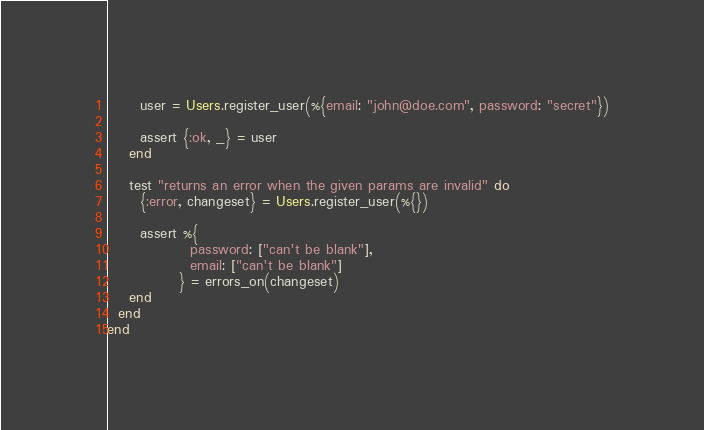<code> <loc_0><loc_0><loc_500><loc_500><_Elixir_>      user = Users.register_user(%{email: "john@doe.com", password: "secret"})

      assert {:ok, _} = user
    end

    test "returns an error when the given params are invalid" do
      {:error, changeset} = Users.register_user(%{})

      assert %{
               password: ["can't be blank"],
               email: ["can't be blank"]
             } = errors_on(changeset)
    end
  end
end
</code> 